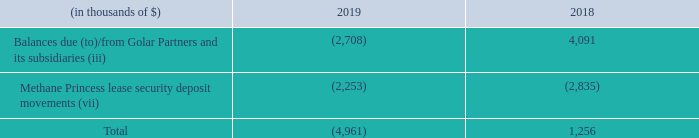Receivables (payables): The balances with Golar Partners and subsidiaries as of December 31, 2019 and 2018 consisted of the following:
(iii) Interest income on short-term loan, balances due(to)/from Golar Partners and its subsidiaries - Receivables and payables with Golar Partners and its subsidiaries comprise primarily of unpaid management fees and expenses for management, advisory and administrative services, dividends in respect of the Hilli Common Units and other related party arrangements including the Hilli Disposal. In addition, certain receivables and payables arise when we pay an invoice on behalf of a related party and vice versa. Receivables and payables are generally settled quarterly in arrears. Balances owing to or due from Golar Partners and its subsidiaries are unsecured, interest-free and intended to be settled in the ordinary course of business. In November 2019, we loaned $15.0 million to Golar Partners, with interest of LIBOR plus 5.0%. The loan was fully repaid, including interest of $0.1 million, in December 2019.
(vii) Methane Princess lease security deposit movements - This represents net advances from Golar Partners since its IPO, which correspond with the net release of funds from the security deposits held relating to a lease for the Methane Princess. This is in connection with the Methane Princess tax lease indemnity provided to Golar Partners under the Omnibus Agreement. Accordingly, these amounts will be settled as part of the eventual termination of the Methane Princess lease.
What does Methane Princess lease security deposit movement represent? Net advances from golar partners since its ipo, which correspond with the net release of funds from the security deposits held relating to a lease for the methane princess. In which years was the receivables (payables) recorded for? 2019, 2018. How often are receivables and payables generally settled? Quarterly in arrears. Which year was the balances due (to)/from Golar Partners and its subsidiaries higher? 4,091 > (2,708)
Answer: 2018. What was the change in Methane Princess lease security deposit movements between 2018 and 2019?
Answer scale should be: thousand. (2,253) - (2,835) 
Answer: 582. What was the percentage change in total between 2018 and 2019?
Answer scale should be: percent. ((4,961)- 1,256)/1,256 
Answer: -494.98. 